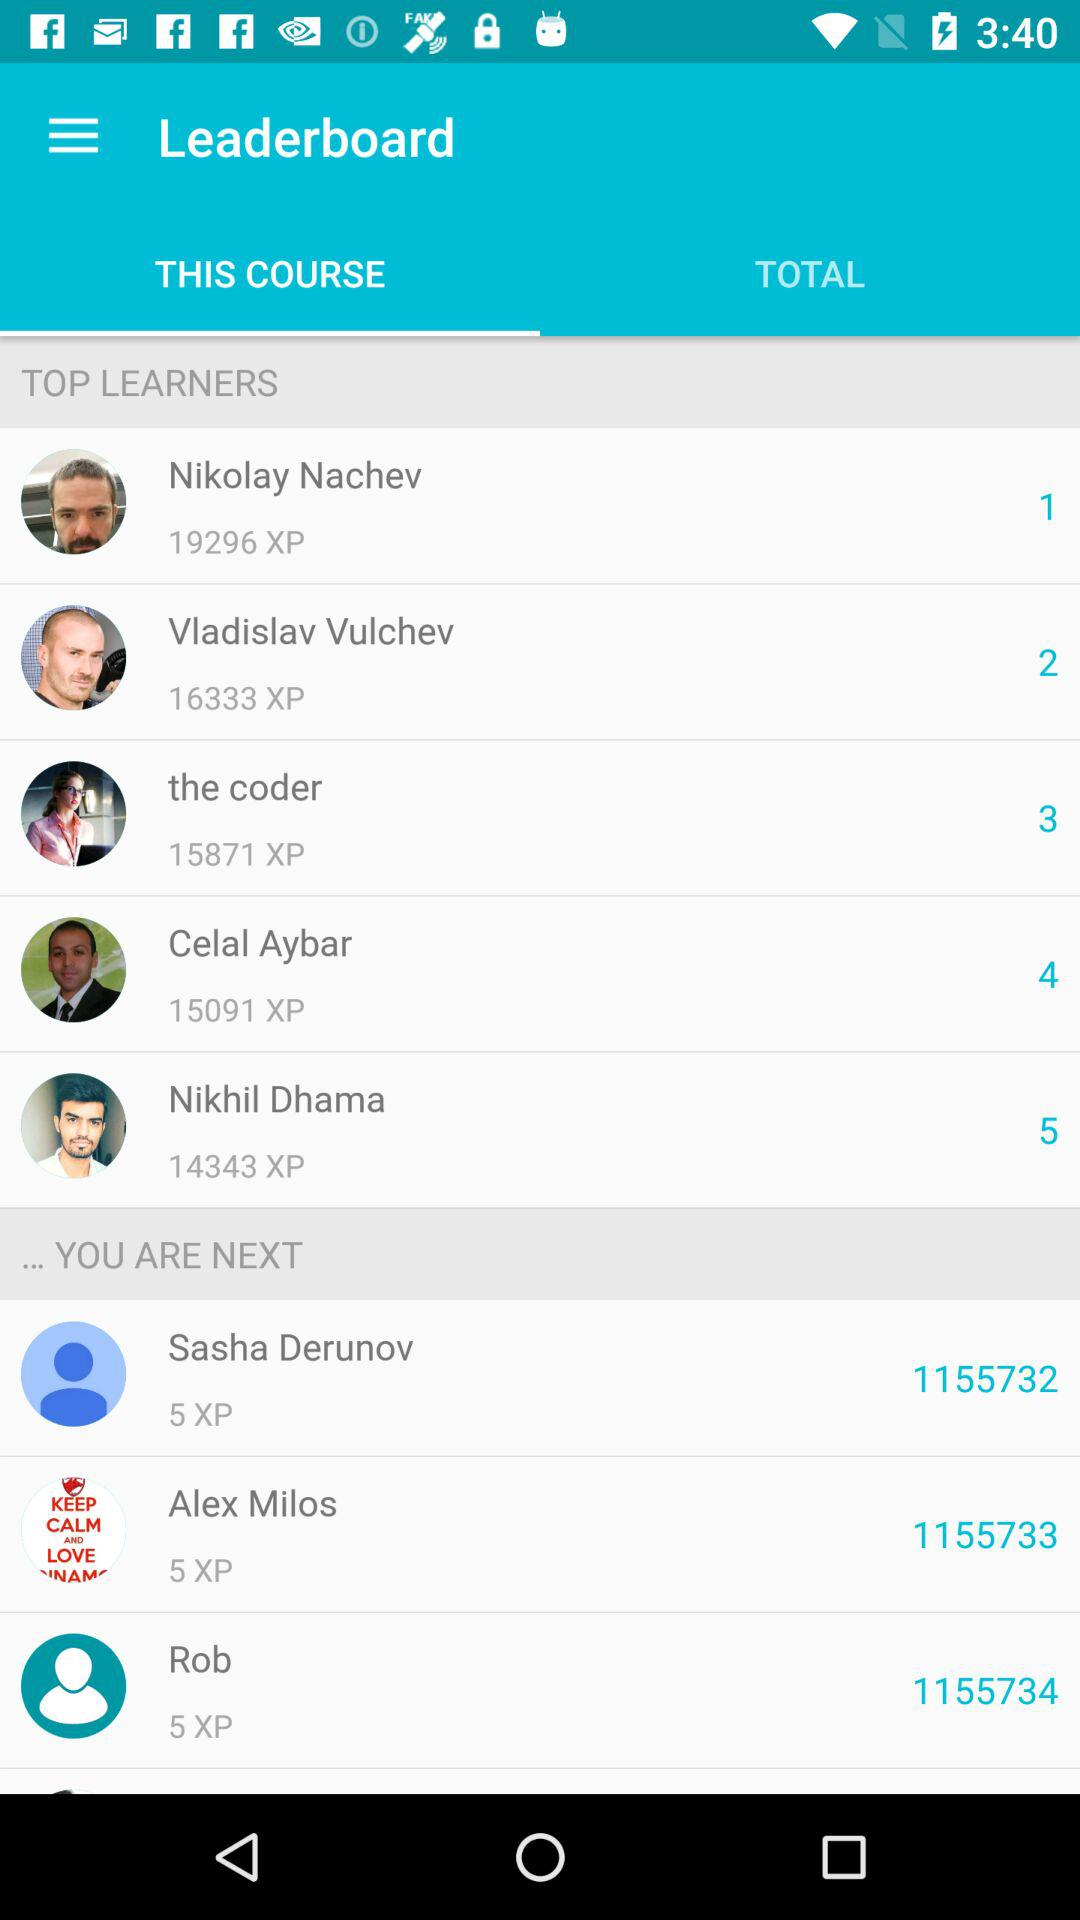How many users are in the top 5 of this leaderboard?
Answer the question using a single word or phrase. 5 